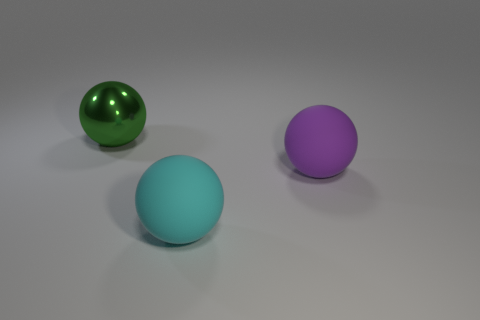Add 3 balls. How many objects exist? 6 Add 2 large cyan rubber objects. How many large cyan rubber objects exist? 3 Subtract 1 purple balls. How many objects are left? 2 Subtract all large purple things. Subtract all large purple matte balls. How many objects are left? 1 Add 2 large shiny balls. How many large shiny balls are left? 3 